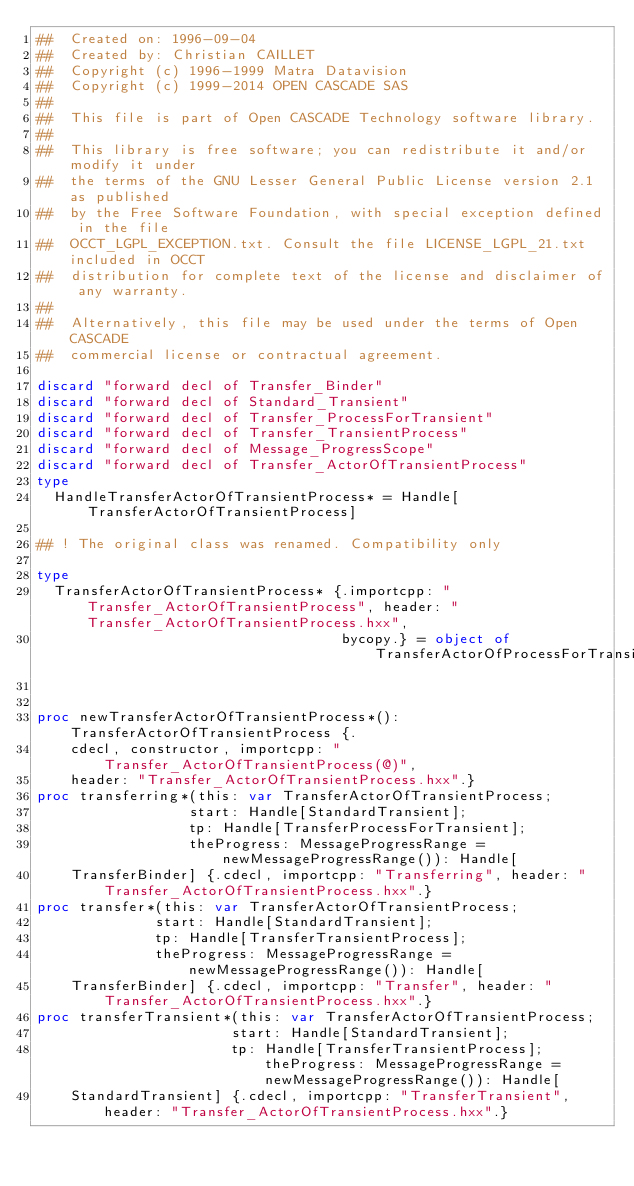Convert code to text. <code><loc_0><loc_0><loc_500><loc_500><_Nim_>##  Created on: 1996-09-04
##  Created by: Christian CAILLET
##  Copyright (c) 1996-1999 Matra Datavision
##  Copyright (c) 1999-2014 OPEN CASCADE SAS
##
##  This file is part of Open CASCADE Technology software library.
##
##  This library is free software; you can redistribute it and/or modify it under
##  the terms of the GNU Lesser General Public License version 2.1 as published
##  by the Free Software Foundation, with special exception defined in the file
##  OCCT_LGPL_EXCEPTION.txt. Consult the file LICENSE_LGPL_21.txt included in OCCT
##  distribution for complete text of the license and disclaimer of any warranty.
##
##  Alternatively, this file may be used under the terms of Open CASCADE
##  commercial license or contractual agreement.

discard "forward decl of Transfer_Binder"
discard "forward decl of Standard_Transient"
discard "forward decl of Transfer_ProcessForTransient"
discard "forward decl of Transfer_TransientProcess"
discard "forward decl of Message_ProgressScope"
discard "forward decl of Transfer_ActorOfTransientProcess"
type
  HandleTransferActorOfTransientProcess* = Handle[TransferActorOfTransientProcess]

## ! The original class was renamed. Compatibility only

type
  TransferActorOfTransientProcess* {.importcpp: "Transfer_ActorOfTransientProcess", header: "Transfer_ActorOfTransientProcess.hxx",
                                    bycopy.} = object of TransferActorOfProcessForTransient


proc newTransferActorOfTransientProcess*(): TransferActorOfTransientProcess {.
    cdecl, constructor, importcpp: "Transfer_ActorOfTransientProcess(@)",
    header: "Transfer_ActorOfTransientProcess.hxx".}
proc transferring*(this: var TransferActorOfTransientProcess;
                  start: Handle[StandardTransient];
                  tp: Handle[TransferProcessForTransient];
                  theProgress: MessageProgressRange = newMessageProgressRange()): Handle[
    TransferBinder] {.cdecl, importcpp: "Transferring", header: "Transfer_ActorOfTransientProcess.hxx".}
proc transfer*(this: var TransferActorOfTransientProcess;
              start: Handle[StandardTransient];
              tp: Handle[TransferTransientProcess];
              theProgress: MessageProgressRange = newMessageProgressRange()): Handle[
    TransferBinder] {.cdecl, importcpp: "Transfer", header: "Transfer_ActorOfTransientProcess.hxx".}
proc transferTransient*(this: var TransferActorOfTransientProcess;
                       start: Handle[StandardTransient];
                       tp: Handle[TransferTransientProcess]; theProgress: MessageProgressRange = newMessageProgressRange()): Handle[
    StandardTransient] {.cdecl, importcpp: "TransferTransient", header: "Transfer_ActorOfTransientProcess.hxx".}</code> 